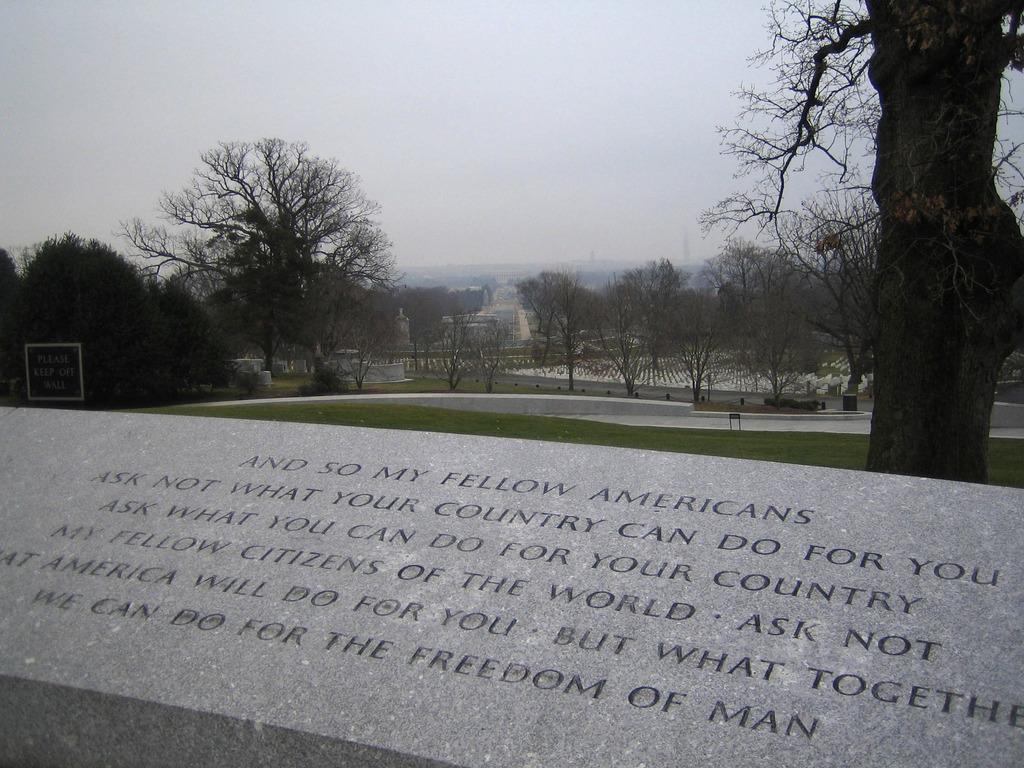Please provide a concise description of this image. In this image I can see the ash colored surface and few words written on it, some grass, few trees and a board. In the background I can see few buildings, few trees and the sky. 